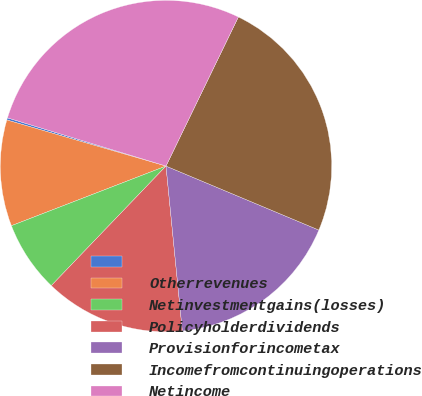<chart> <loc_0><loc_0><loc_500><loc_500><pie_chart><ecel><fcel>Otherrevenues<fcel>Netinvestmentgains(losses)<fcel>Policyholderdividends<fcel>Provisionforincometax<fcel>Incomefromcontinuingoperations<fcel>Netincome<nl><fcel>0.21%<fcel>10.35%<fcel>6.97%<fcel>13.74%<fcel>17.12%<fcel>24.12%<fcel>27.5%<nl></chart> 